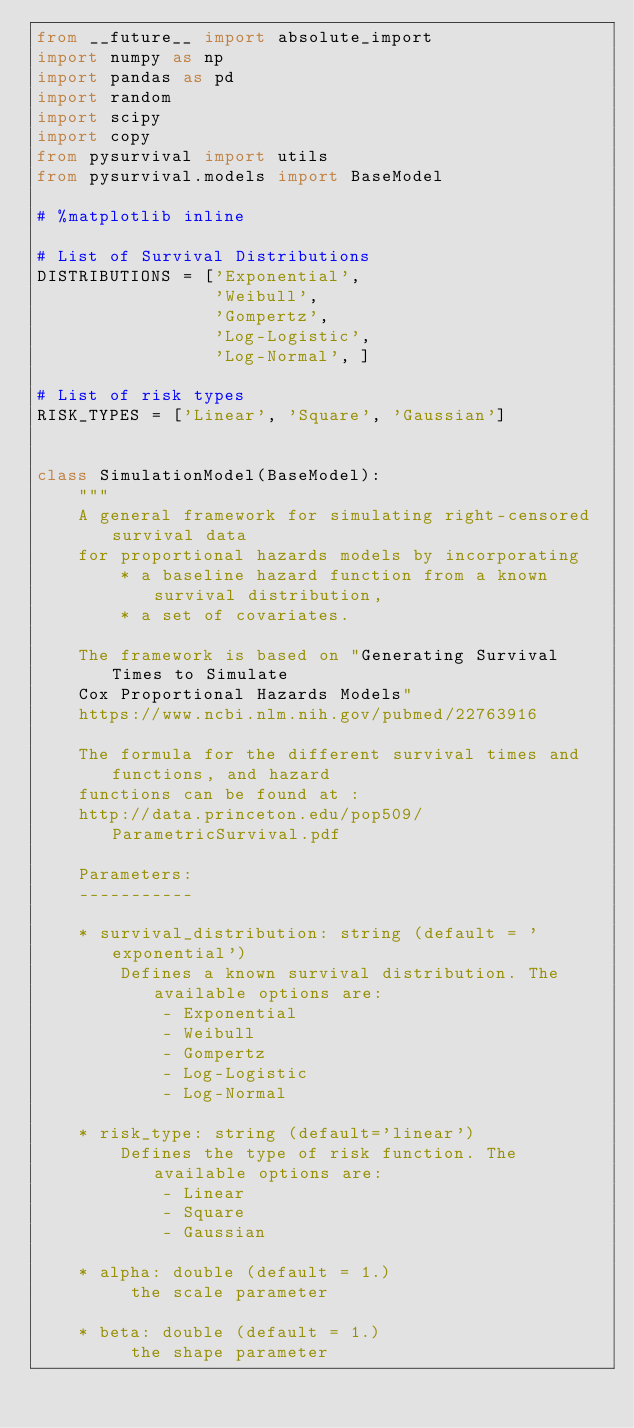<code> <loc_0><loc_0><loc_500><loc_500><_Python_>from __future__ import absolute_import
import numpy as np
import pandas as pd
import random
import scipy
import copy
from pysurvival import utils
from pysurvival.models import BaseModel

# %matplotlib inline

# List of Survival Distributions
DISTRIBUTIONS = ['Exponential',
                 'Weibull',
                 'Gompertz',
                 'Log-Logistic',
                 'Log-Normal', ]

# List of risk types
RISK_TYPES = ['Linear', 'Square', 'Gaussian']


class SimulationModel(BaseModel):
    """ 
    A general framework for simulating right-censored survival data 
    for proportional hazards models by incorporating 
        * a baseline hazard function from a known survival distribution, 
        * a set of covariates. 
    
    The framework is based on "Generating Survival Times to Simulate 
    Cox Proportional Hazards Models"
    https://www.ncbi.nlm.nih.gov/pubmed/22763916

    The formula for the different survival times and functions, and hazard
    functions can be found at :
    http://data.princeton.edu/pop509/ParametricSurvival.pdf

    Parameters:
    -----------

    * survival_distribution: string (default = 'exponential')
        Defines a known survival distribution. The available options are:
            - Exponential
            - Weibull
            - Gompertz
            - Log-Logistic
            - Log-Normal
        
    * risk_type: string (default='linear')
        Defines the type of risk function. The available options are:
            - Linear
            - Square
            - Gaussian
        
    * alpha: double (default = 1.) 
         the scale parameter

    * beta: double (default = 1.)
         the shape parameter
         </code> 